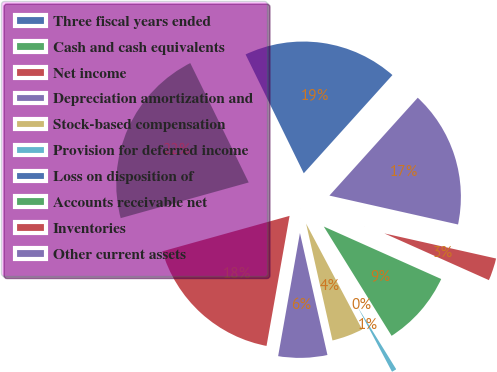Convert chart. <chart><loc_0><loc_0><loc_500><loc_500><pie_chart><fcel>Three fiscal years ended<fcel>Cash and cash equivalents<fcel>Net income<fcel>Depreciation amortization and<fcel>Stock-based compensation<fcel>Provision for deferred income<fcel>Loss on disposition of<fcel>Accounts receivable net<fcel>Inventories<fcel>Other current assets<nl><fcel>18.93%<fcel>22.08%<fcel>17.88%<fcel>6.32%<fcel>4.22%<fcel>1.07%<fcel>0.02%<fcel>9.47%<fcel>3.17%<fcel>16.83%<nl></chart> 